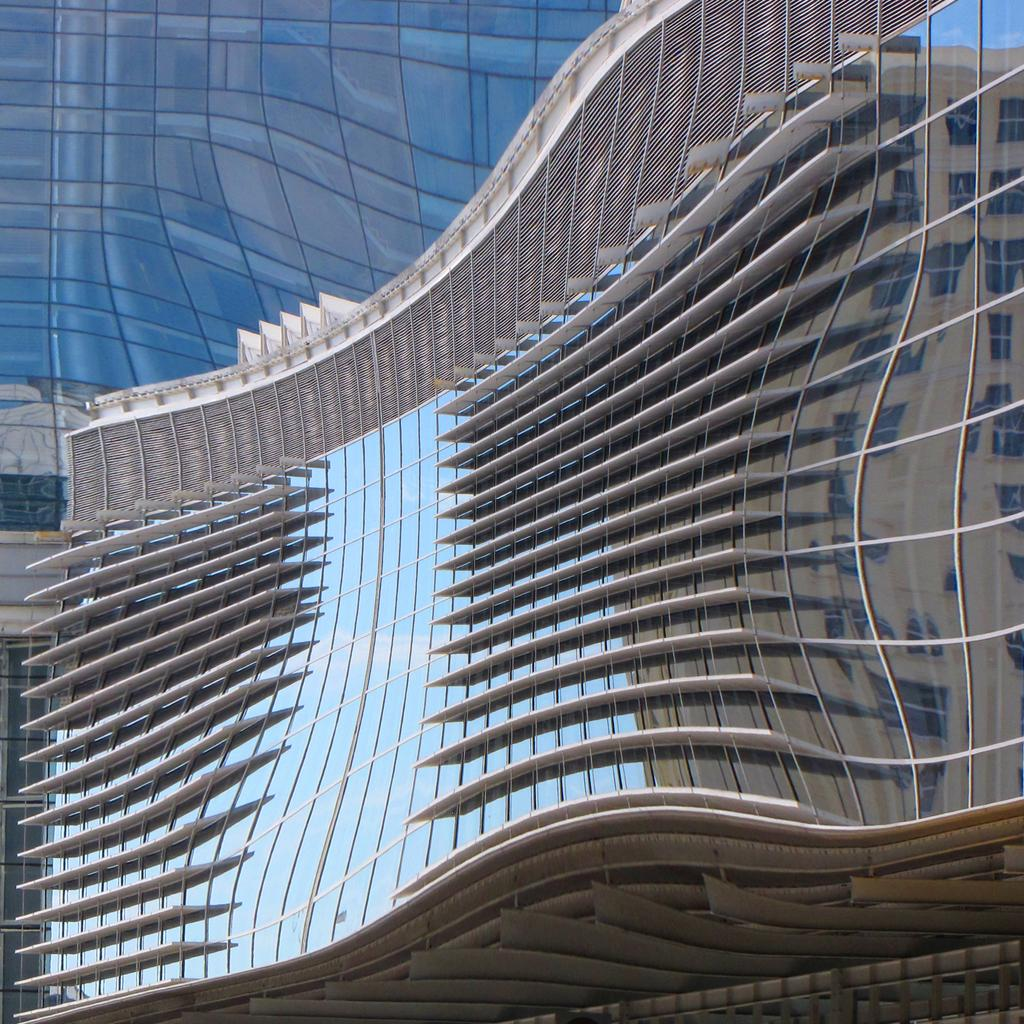What type of buildings are visible in the image? There are glass buildings in the image. What type of oatmeal is being served in the glass buildings in the image? There is no oatmeal or any indication of food in the image; it only features glass buildings. 